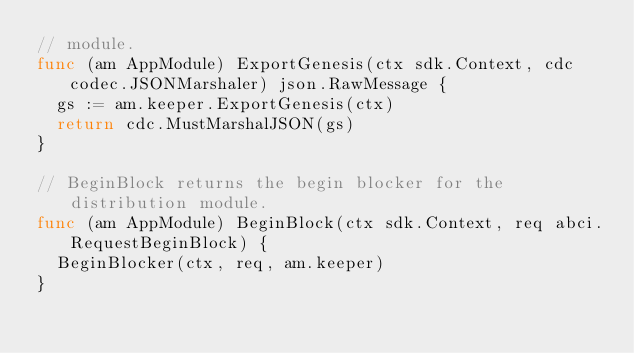Convert code to text. <code><loc_0><loc_0><loc_500><loc_500><_Go_>// module.
func (am AppModule) ExportGenesis(ctx sdk.Context, cdc codec.JSONMarshaler) json.RawMessage {
	gs := am.keeper.ExportGenesis(ctx)
	return cdc.MustMarshalJSON(gs)
}

// BeginBlock returns the begin blocker for the distribution module.
func (am AppModule) BeginBlock(ctx sdk.Context, req abci.RequestBeginBlock) {
	BeginBlocker(ctx, req, am.keeper)
}
</code> 